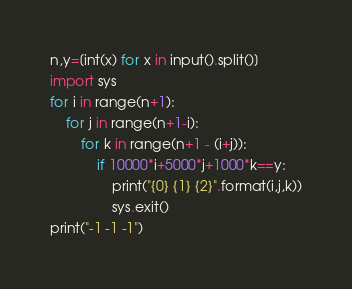<code> <loc_0><loc_0><loc_500><loc_500><_Python_>n,y=[int(x) for x in input().split()]
import sys
for i in range(n+1):
    for j in range(n+1-i):
        for k in range(n+1 - (i+j)):
            if 10000*i+5000*j+1000*k==y:
                print("{0} {1} {2}".format(i,j,k))
                sys.exit()
print("-1 -1 -1")</code> 